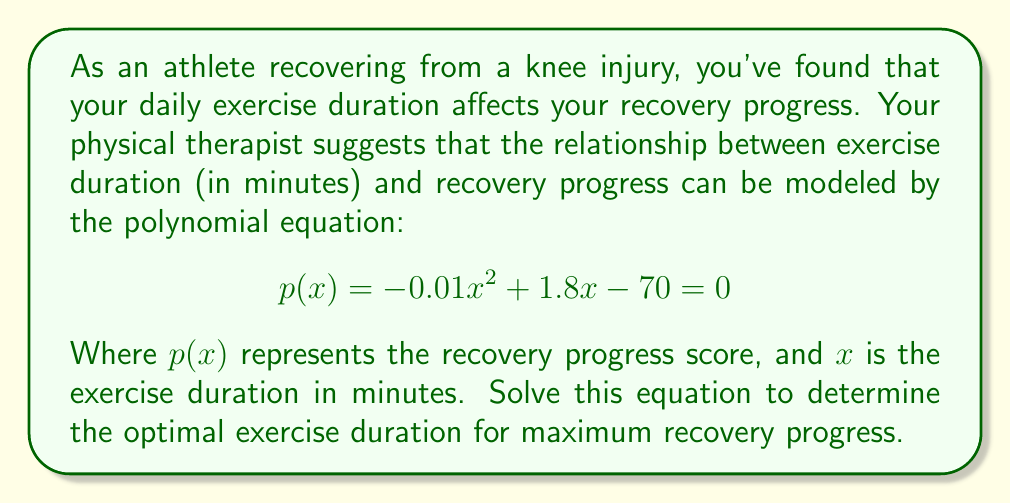Can you answer this question? To solve this polynomial equation, we'll follow these steps:

1) First, recognize that this is a quadratic equation in the form $ax^2 + bx + c = 0$, where:
   $a = -0.01$
   $b = 1.8$
   $c = -70$

2) We can solve this using the quadratic formula: $x = \frac{-b \pm \sqrt{b^2 - 4ac}}{2a}$

3) Let's substitute our values:

   $$x = \frac{-1.8 \pm \sqrt{1.8^2 - 4(-0.01)(-70)}}{2(-0.01)}$$

4) Simplify under the square root:

   $$x = \frac{-1.8 \pm \sqrt{3.24 + 2.8}}{-0.02}$$
   $$x = \frac{-1.8 \pm \sqrt{6.04}}{-0.02}$$

5) Simplify the square root:

   $$x = \frac{-1.8 \pm 2.458}{-0.02}$$

6) Now we have two solutions:

   $$x = \frac{-1.8 + 2.458}{-0.02} \text{ or } x = \frac{-1.8 - 2.458}{-0.02}$$

7) Simplify:

   $$x = \frac{0.658}{-0.02} = -32.9 \text{ or } x = \frac{-4.258}{-0.02} = 212.9$$

8) Since exercise duration can't be negative, we discard the negative solution.

9) Round to the nearest whole number as exercise duration is typically measured in whole minutes.

Therefore, the optimal exercise duration for maximum recovery progress is approximately 90 minutes.
Answer: 90 minutes 